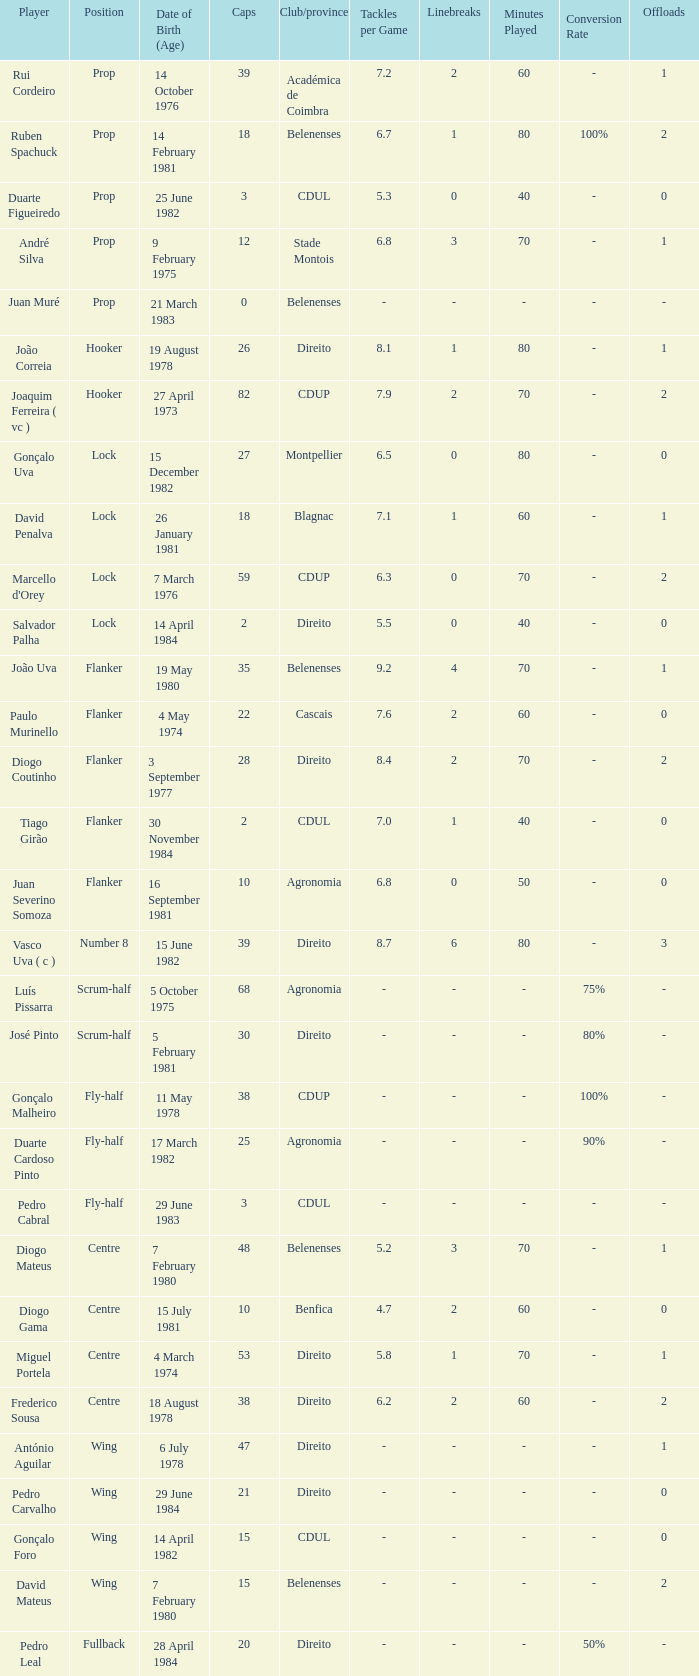Which player has a Club/province of direito, less than 21 caps, and a Position of lock? Salvador Palha. I'm looking to parse the entire table for insights. Could you assist me with that? {'header': ['Player', 'Position', 'Date of Birth (Age)', 'Caps', 'Club/province', 'Tackles per Game', 'Linebreaks', 'Minutes Played', 'Conversion Rate', 'Offloads'], 'rows': [['Rui Cordeiro', 'Prop', '14 October 1976', '39', 'Académica de Coimbra', '7.2', '2', '60', '-', '1'], ['Ruben Spachuck', 'Prop', '14 February 1981', '18', 'Belenenses', '6.7', '1', '80', '100%', '2'], ['Duarte Figueiredo', 'Prop', '25 June 1982', '3', 'CDUL', '5.3', '0', '40', '-', '0'], ['André Silva', 'Prop', '9 February 1975', '12', 'Stade Montois', '6.8', '3', '70', '-', '1'], ['Juan Muré', 'Prop', '21 March 1983', '0', 'Belenenses', '-', '-', '-', '-', '-'], ['João Correia', 'Hooker', '19 August 1978', '26', 'Direito', '8.1', '1', '80', '-', '1'], ['Joaquim Ferreira ( vc )', 'Hooker', '27 April 1973', '82', 'CDUP', '7.9', '2', '70', '-', '2'], ['Gonçalo Uva', 'Lock', '15 December 1982', '27', 'Montpellier', '6.5', '0', '80', '-', '0'], ['David Penalva', 'Lock', '26 January 1981', '18', 'Blagnac', '7.1', '1', '60', '-', '1'], ["Marcello d'Orey", 'Lock', '7 March 1976', '59', 'CDUP', '6.3', '0', '70', '-', '2'], ['Salvador Palha', 'Lock', '14 April 1984', '2', 'Direito', '5.5', '0', '40', '-', '0'], ['João Uva', 'Flanker', '19 May 1980', '35', 'Belenenses', '9.2', '4', '70', '-', '1'], ['Paulo Murinello', 'Flanker', '4 May 1974', '22', 'Cascais', '7.6', '2', '60', '-', '0'], ['Diogo Coutinho', 'Flanker', '3 September 1977', '28', 'Direito', '8.4', '2', '70', '-', '2'], ['Tiago Girão', 'Flanker', '30 November 1984', '2', 'CDUL', '7.0', '1', '40', '-', '0'], ['Juan Severino Somoza', 'Flanker', '16 September 1981', '10', 'Agronomia', '6.8', '0', '50', '-', '0'], ['Vasco Uva ( c )', 'Number 8', '15 June 1982', '39', 'Direito', '8.7', '6', '80', '-', '3'], ['Luís Pissarra', 'Scrum-half', '5 October 1975', '68', 'Agronomia', '-', '-', '-', '75%', '-'], ['José Pinto', 'Scrum-half', '5 February 1981', '30', 'Direito', '-', '-', '-', '80%', '-'], ['Gonçalo Malheiro', 'Fly-half', '11 May 1978', '38', 'CDUP', '-', '-', '-', '100%', '-'], ['Duarte Cardoso Pinto', 'Fly-half', '17 March 1982', '25', 'Agronomia', '-', '-', '-', '90%', '-'], ['Pedro Cabral', 'Fly-half', '29 June 1983', '3', 'CDUL', '-', '-', '-', '-', '-'], ['Diogo Mateus', 'Centre', '7 February 1980', '48', 'Belenenses', '5.2', '3', '70', '-', '1'], ['Diogo Gama', 'Centre', '15 July 1981', '10', 'Benfica', '4.7', '2', '60', '-', '0'], ['Miguel Portela', 'Centre', '4 March 1974', '53', 'Direito', '5.8', '1', '70', '-', '1'], ['Frederico Sousa', 'Centre', '18 August 1978', '38', 'Direito', '6.2', '2', '60', '-', '2'], ['António Aguilar', 'Wing', '6 July 1978', '47', 'Direito', '-', '-', '-', '-', '1'], ['Pedro Carvalho', 'Wing', '29 June 1984', '21', 'Direito', '-', '-', '-', '-', '0'], ['Gonçalo Foro', 'Wing', '14 April 1982', '15', 'CDUL', '-', '-', '-', '-', '0'], ['David Mateus', 'Wing', '7 February 1980', '15', 'Belenenses', '-', '-', '-', '-', '2'], ['Pedro Leal', 'Fullback', '28 April 1984', '20', 'Direito', '-', '-', '-', '50%', '-']]} 